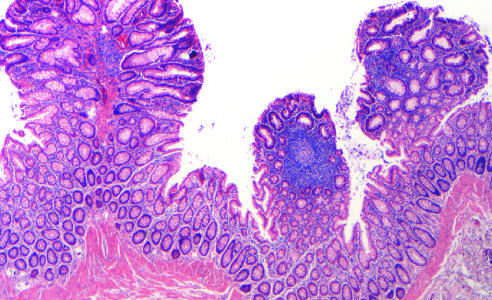what are present in this single microscopic field?
Answer the question using a single word or phrase. Three tubular adenomas 